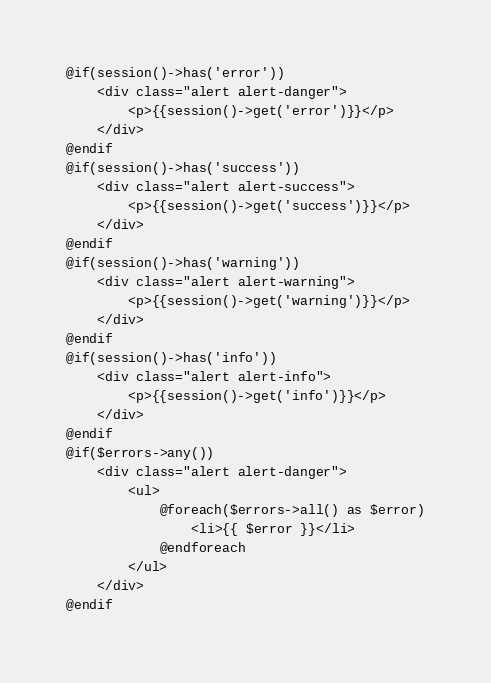<code> <loc_0><loc_0><loc_500><loc_500><_PHP_>@if(session()->has('error'))
    <div class="alert alert-danger">
        <p>{{session()->get('error')}}</p>
    </div>
@endif
@if(session()->has('success'))
    <div class="alert alert-success">
        <p>{{session()->get('success')}}</p>
    </div>
@endif
@if(session()->has('warning'))
    <div class="alert alert-warning">
        <p>{{session()->get('warning')}}</p>
    </div>
@endif
@if(session()->has('info'))
    <div class="alert alert-info">
        <p>{{session()->get('info')}}</p>
    </div>
@endif
@if($errors->any())
    <div class="alert alert-danger">
        <ul>
            @foreach($errors->all() as $error)
                <li>{{ $error }}</li>
            @endforeach
        </ul>
    </div>
@endif</code> 